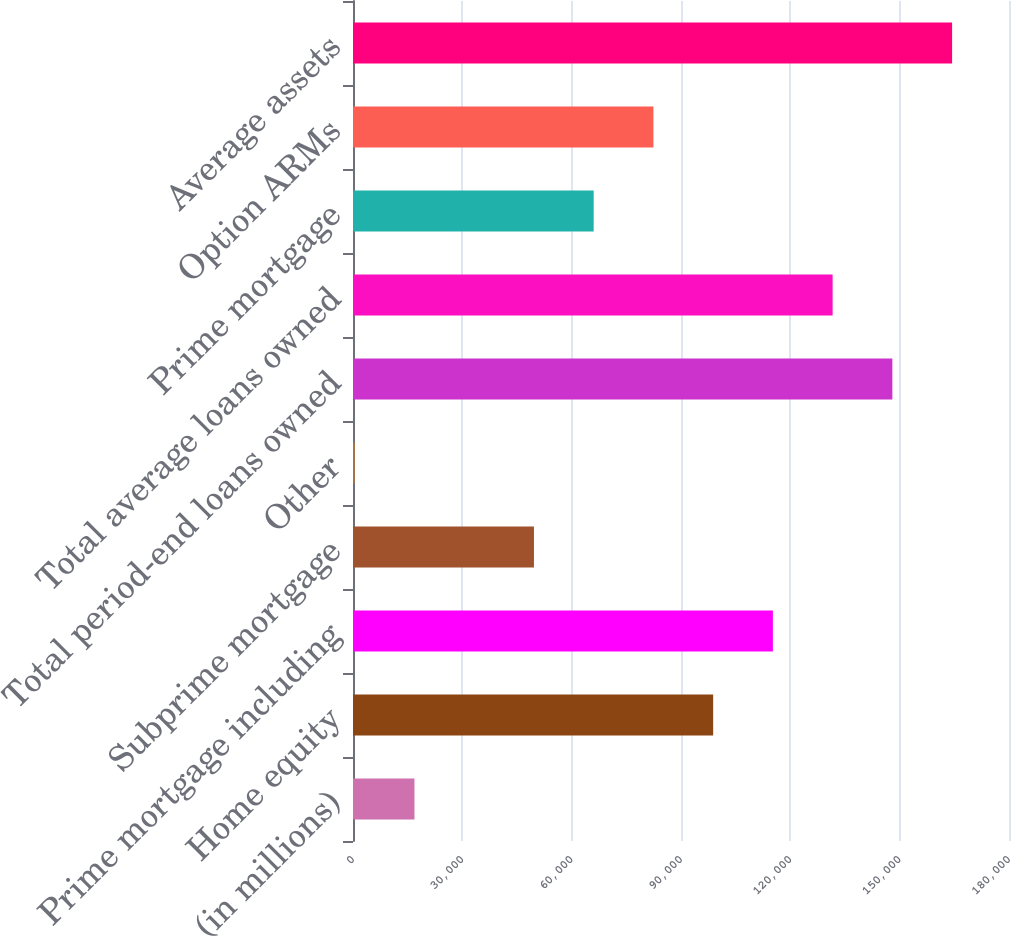Convert chart. <chart><loc_0><loc_0><loc_500><loc_500><bar_chart><fcel>(in millions)<fcel>Home equity<fcel>Prime mortgage including<fcel>Subprime mortgage<fcel>Other<fcel>Total period-end loans owned<fcel>Total average loans owned<fcel>Prime mortgage<fcel>Option ARMs<fcel>Average assets<nl><fcel>16868<fcel>98823<fcel>115214<fcel>49650<fcel>477<fcel>147996<fcel>131605<fcel>66041<fcel>82432<fcel>164387<nl></chart> 